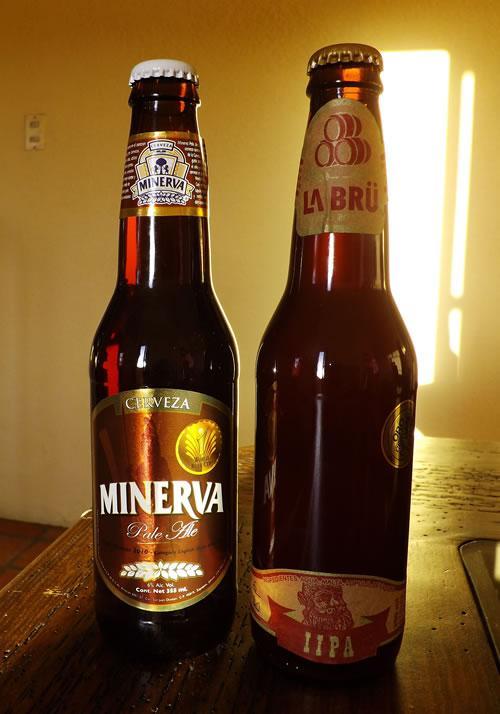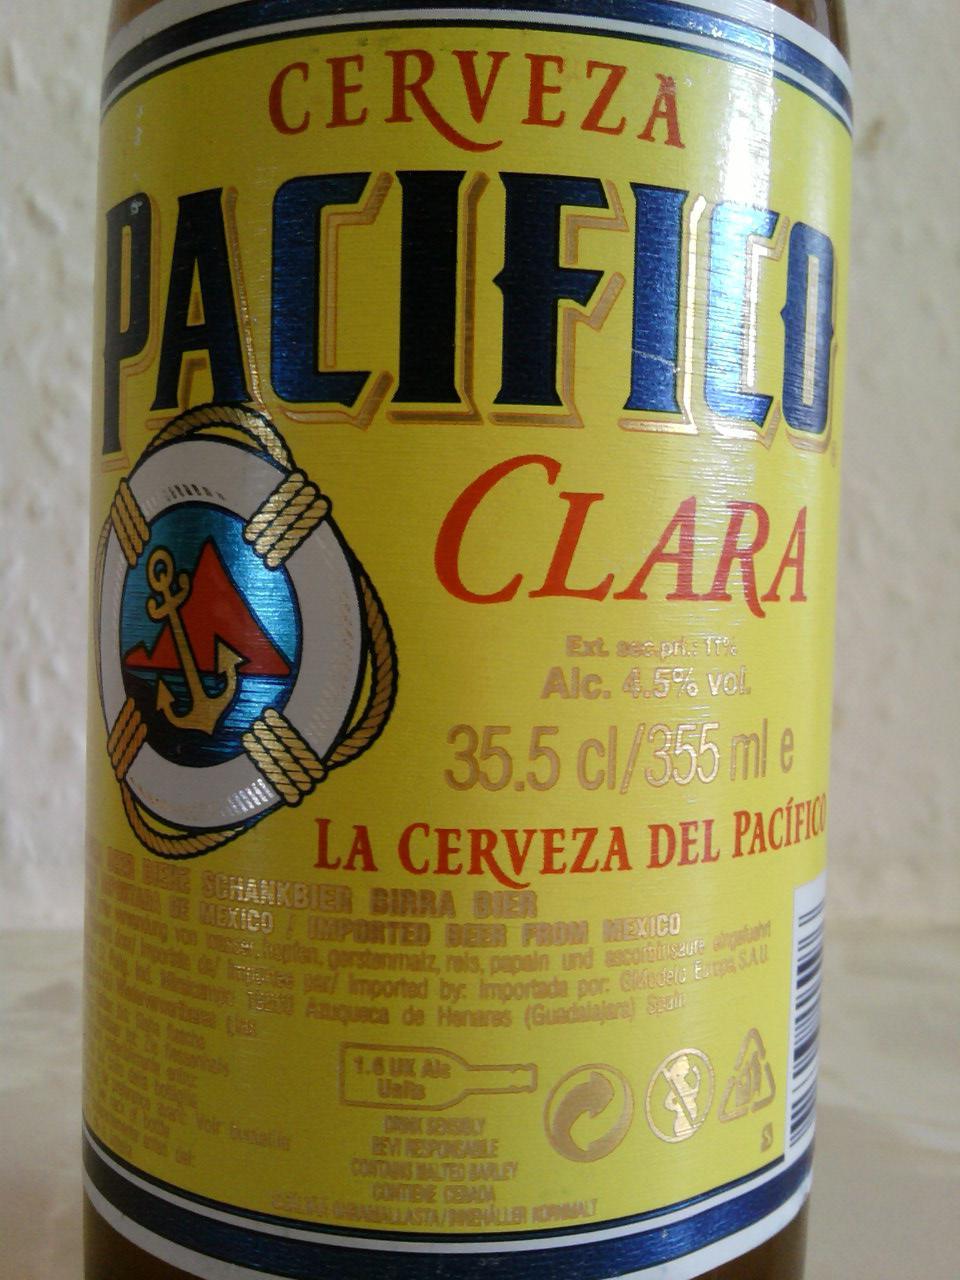The first image is the image on the left, the second image is the image on the right. Given the left and right images, does the statement "One image contains exactly two brown glass beer bottles standing on a table, and no image contains more than three glass bottles." hold true? Answer yes or no. Yes. The first image is the image on the left, the second image is the image on the right. Assess this claim about the two images: "There are exactly two bottles in one of the images.". Correct or not? Answer yes or no. Yes. 